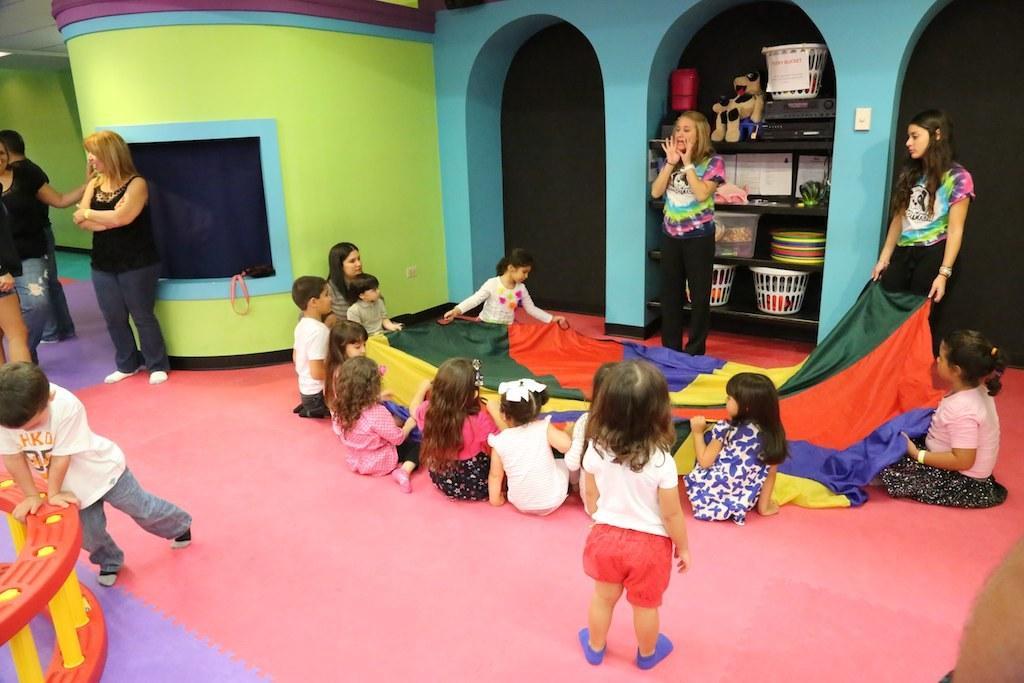Please provide a concise description of this image. In this image there are kids sitting on the floor. They are holding a cloth. In the center there is a woman standing. Behind her there is a shelf. There are baskets and toys in the shelf. To the left there are two women standing. In front of them there is a kid playing. In the background there is a wall. 